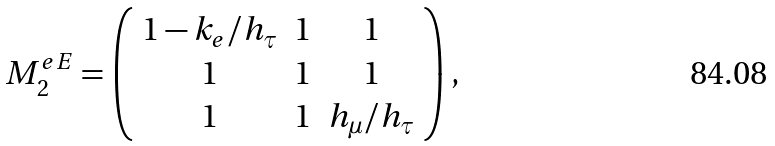Convert formula to latex. <formula><loc_0><loc_0><loc_500><loc_500>M _ { 2 } ^ { e E } = \left ( \begin{array} { c c c } 1 - k _ { e } / h _ { \tau } & 1 & 1 \\ 1 & 1 & 1 \\ 1 & 1 & h _ { \mu } / h _ { \tau } \\ \end{array} \right ) ,</formula> 